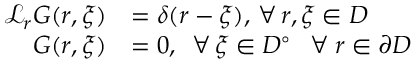<formula> <loc_0><loc_0><loc_500><loc_500>\begin{array} { r l } { \mathcal { L } _ { r } G ( r , \xi ) } & { = \delta ( r - \xi ) , \, \forall \, r , \xi \in D } \\ { G ( r , \xi ) } & { = 0 , \, \forall \, \xi \in D ^ { \circ } \, \forall \, r \in \partial D } \end{array}</formula> 